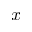<formula> <loc_0><loc_0><loc_500><loc_500>x</formula> 